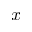<formula> <loc_0><loc_0><loc_500><loc_500>x</formula> 